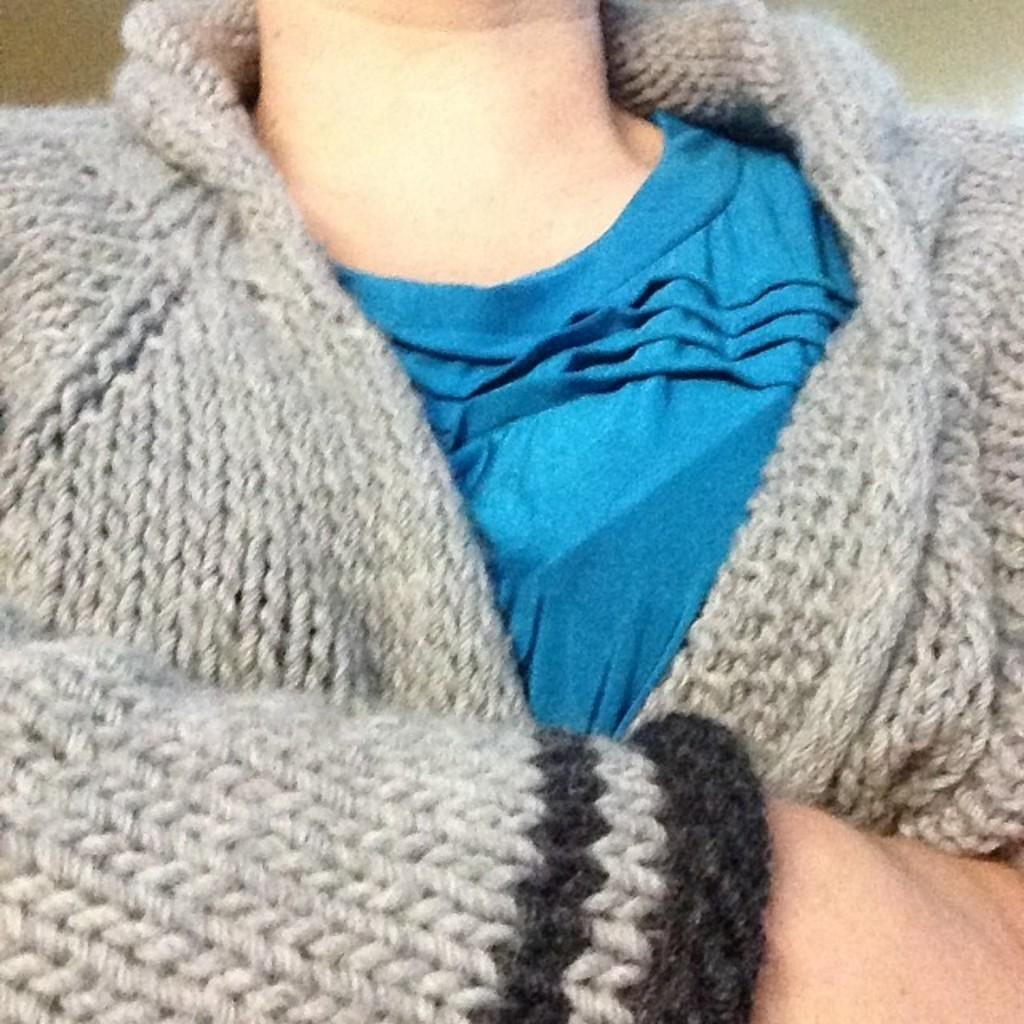Who or what is present in the image? There is a person in the image. What type of clothing is the person wearing on their upper body? The person is wearing a t-shirt and a woolen jacket. What is the condition of the ship in the image? There is no ship present in the image; it only features a person wearing a t-shirt and a woolen jacket. 